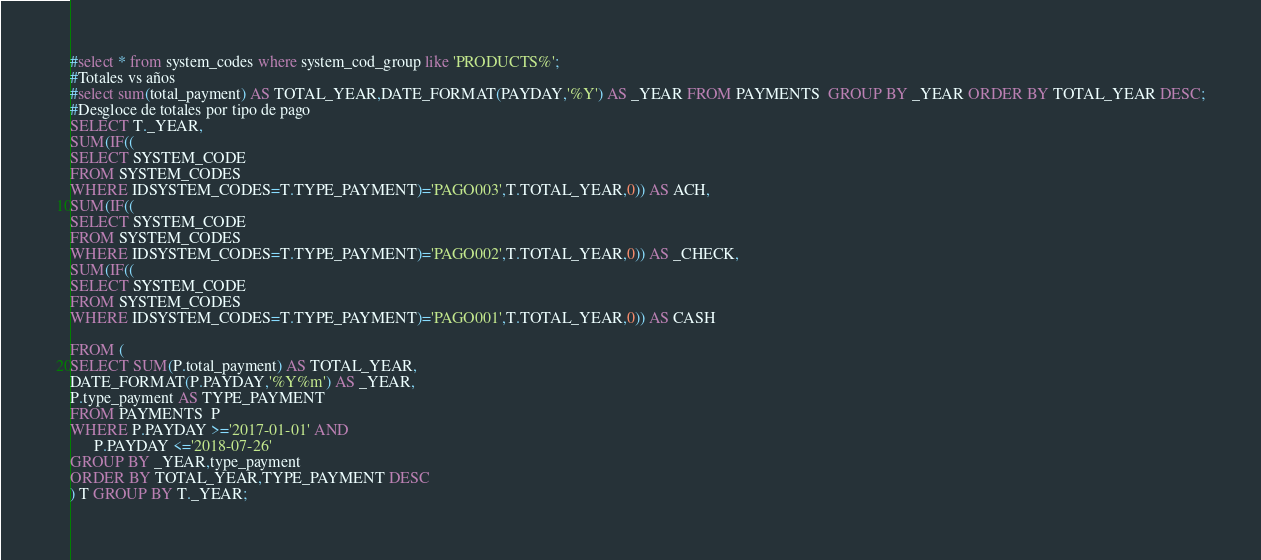Convert code to text. <code><loc_0><loc_0><loc_500><loc_500><_SQL_>#select * from system_codes where system_cod_group like 'PRODUCTS%';
#Totales vs años
#select sum(total_payment) AS TOTAL_YEAR,DATE_FORMAT(PAYDAY,'%Y') AS _YEAR FROM PAYMENTS  GROUP BY _YEAR ORDER BY TOTAL_YEAR DESC;
#Desgloce de totales por tipo de pago
SELECT T._YEAR, 
SUM(IF((
SELECT SYSTEM_CODE 
FROM SYSTEM_CODES 
WHERE IDSYSTEM_CODES=T.TYPE_PAYMENT)='PAGO003',T.TOTAL_YEAR,0)) AS ACH,
SUM(IF((
SELECT SYSTEM_CODE 
FROM SYSTEM_CODES 
WHERE IDSYSTEM_CODES=T.TYPE_PAYMENT)='PAGO002',T.TOTAL_YEAR,0)) AS _CHECK,
SUM(IF((
SELECT SYSTEM_CODE 
FROM SYSTEM_CODES 
WHERE IDSYSTEM_CODES=T.TYPE_PAYMENT)='PAGO001',T.TOTAL_YEAR,0)) AS CASH

FROM (
SELECT SUM(P.total_payment) AS TOTAL_YEAR,
DATE_FORMAT(P.PAYDAY,'%Y%m') AS _YEAR,
P.type_payment AS TYPE_PAYMENT
FROM PAYMENTS  P
WHERE P.PAYDAY >='2017-01-01' AND 
      P.PAYDAY <='2018-07-26'
GROUP BY _YEAR,type_payment 
ORDER BY TOTAL_YEAR,TYPE_PAYMENT DESC
) T GROUP BY T._YEAR;</code> 